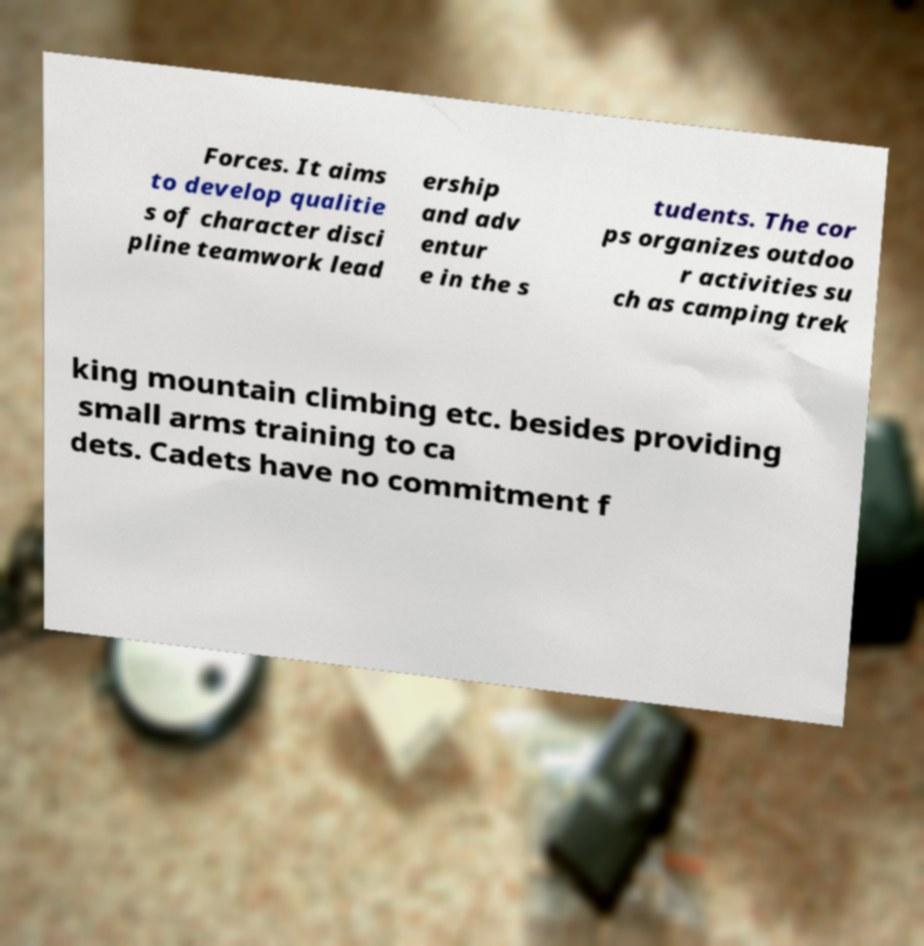Could you extract and type out the text from this image? Forces. It aims to develop qualitie s of character disci pline teamwork lead ership and adv entur e in the s tudents. The cor ps organizes outdoo r activities su ch as camping trek king mountain climbing etc. besides providing small arms training to ca dets. Cadets have no commitment f 